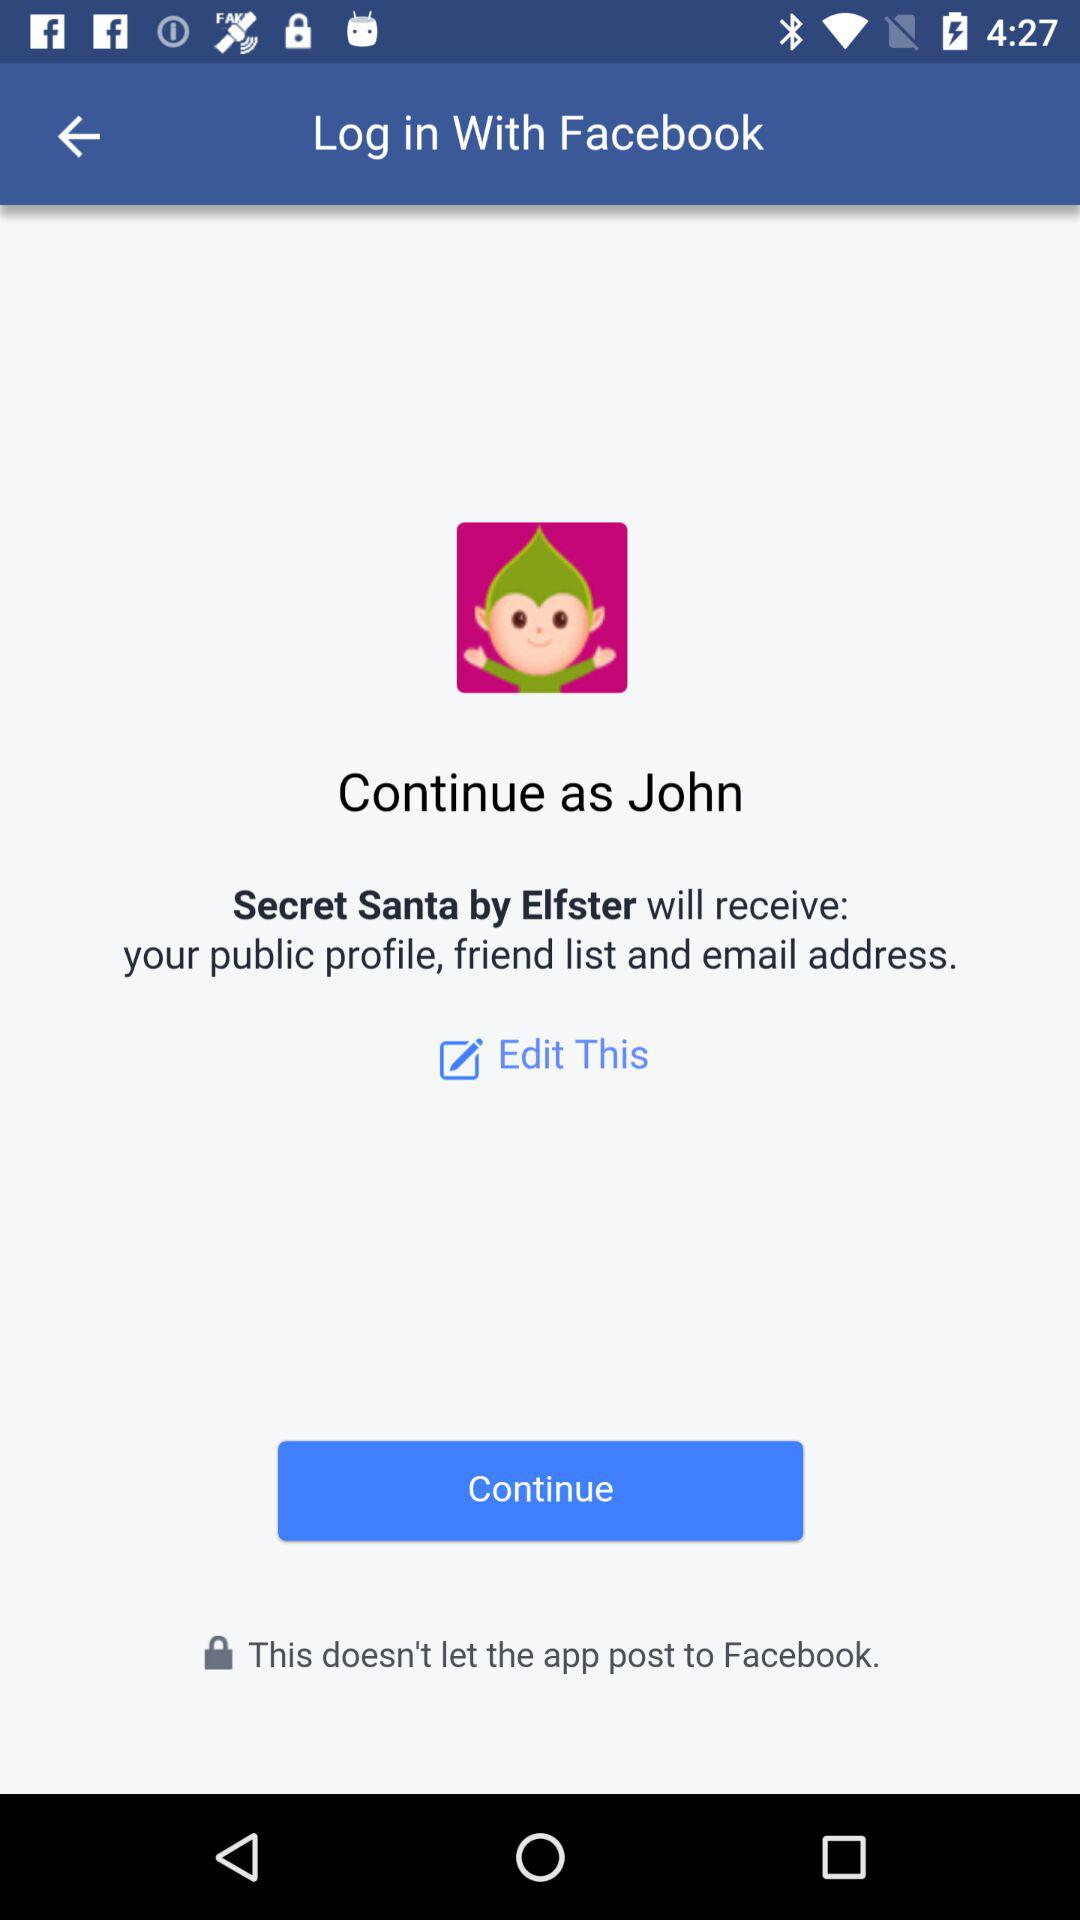Who will receive public profile and email address? The public profile and email address receive by "Secret Santa by Elfster". 